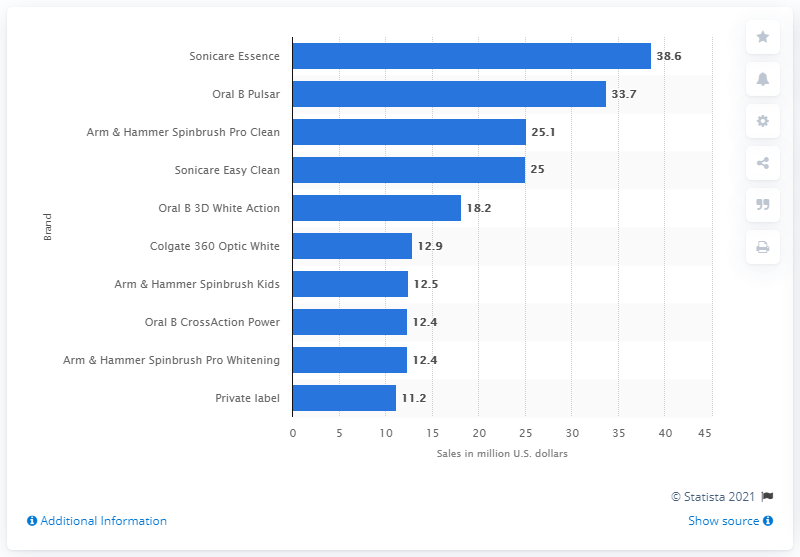Highlight a few significant elements in this photo. In 2014, Sonicare Essence was the top-selling power toothbrush brand in the country. 